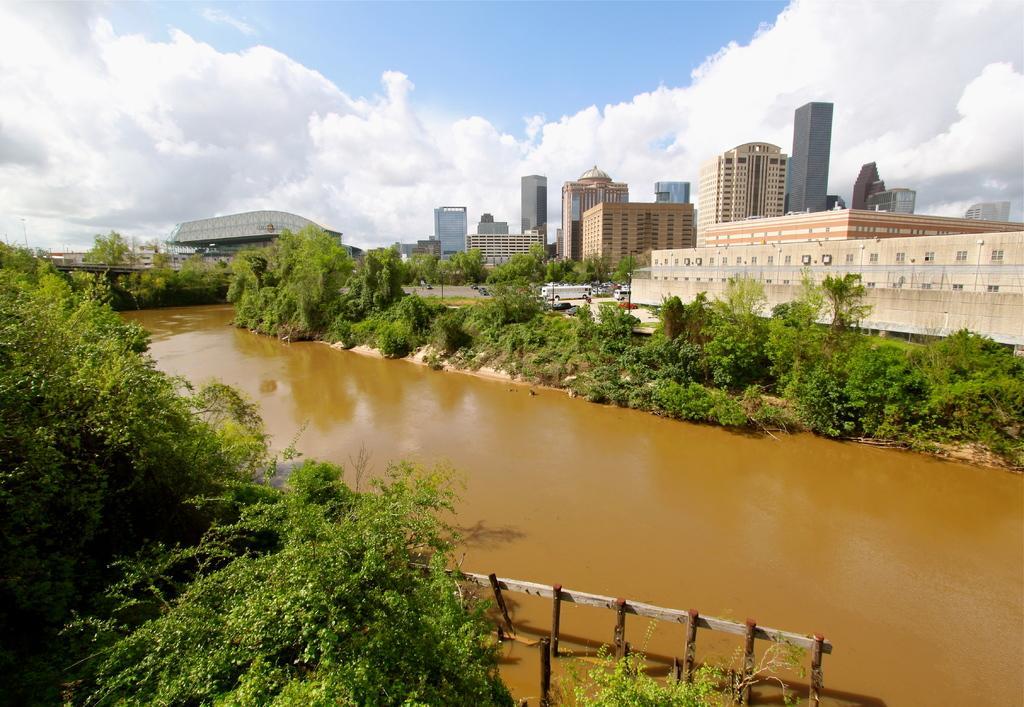Please provide a concise description of this image. Beside this water there are plants and trees. Sky is cloudy. Background there are buildings and vehicles. 